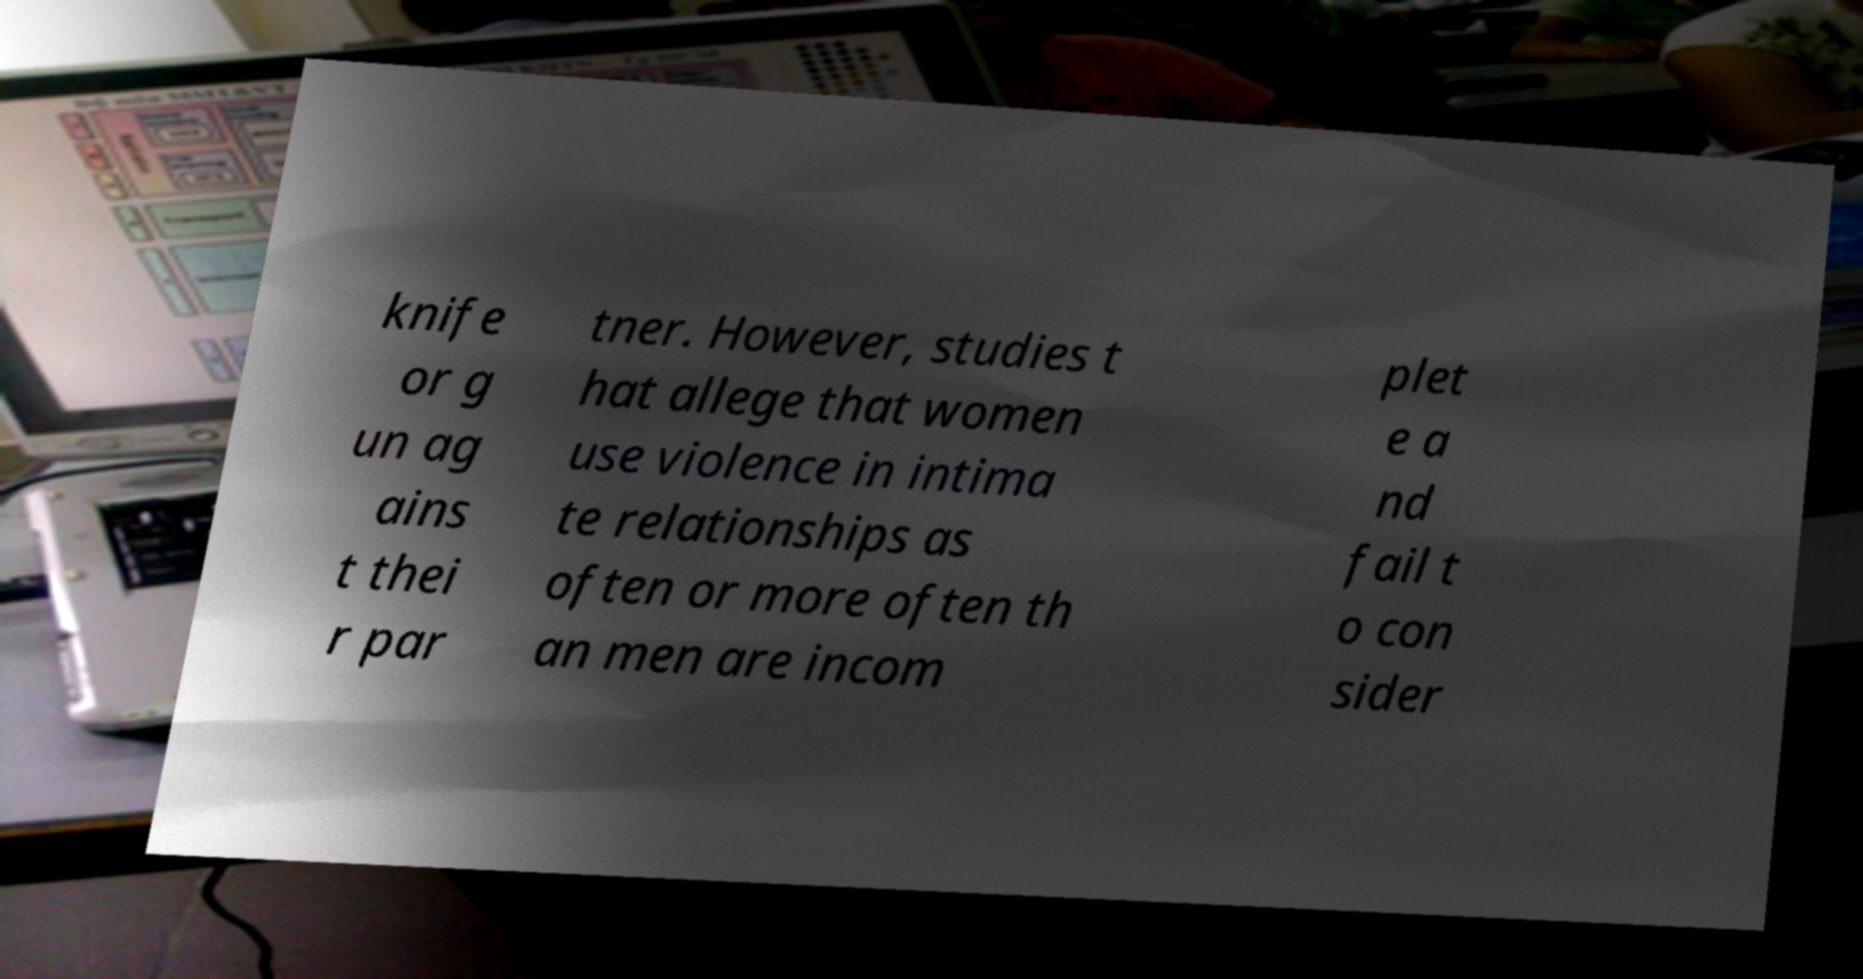What messages or text are displayed in this image? I need them in a readable, typed format. knife or g un ag ains t thei r par tner. However, studies t hat allege that women use violence in intima te relationships as often or more often th an men are incom plet e a nd fail t o con sider 